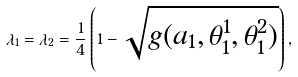Convert formula to latex. <formula><loc_0><loc_0><loc_500><loc_500>\lambda _ { 1 } = \lambda _ { 2 } = \frac { 1 } { 4 } \left ( 1 - \sqrt { g ( a _ { 1 } , \theta _ { 1 } ^ { 1 } , \theta _ { 1 } ^ { 2 } ) } \right ) ,</formula> 